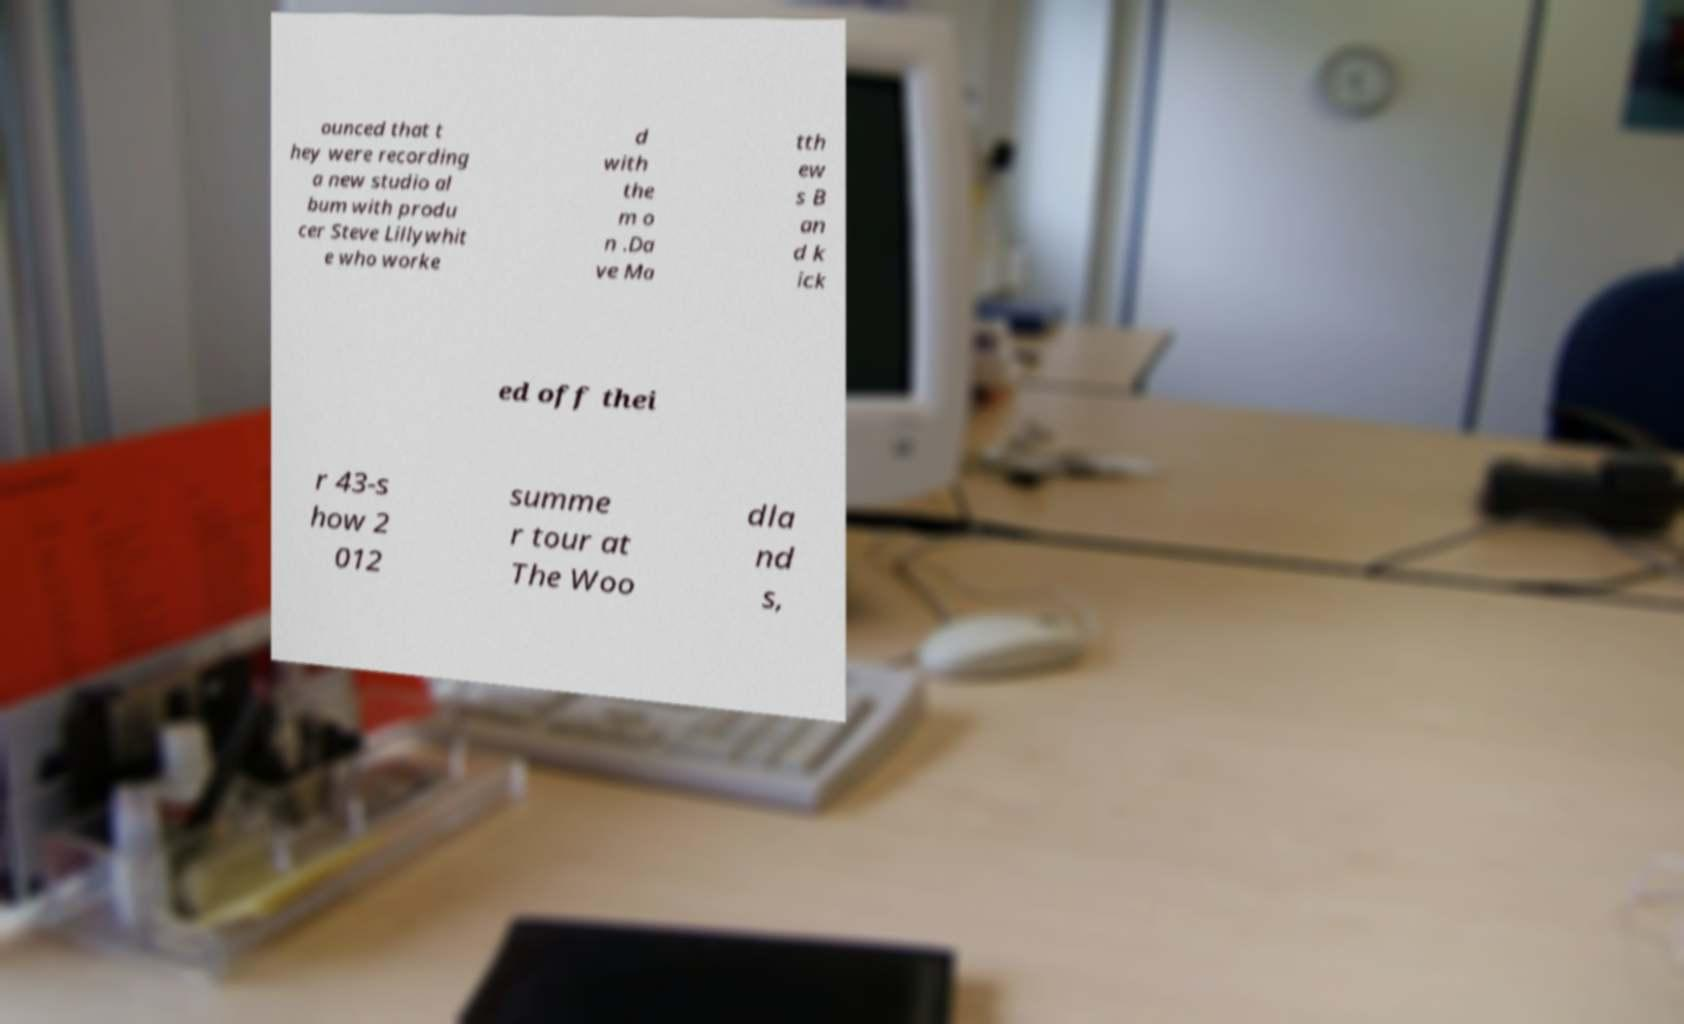For documentation purposes, I need the text within this image transcribed. Could you provide that? ounced that t hey were recording a new studio al bum with produ cer Steve Lillywhit e who worke d with the m o n .Da ve Ma tth ew s B an d k ick ed off thei r 43-s how 2 012 summe r tour at The Woo dla nd s, 